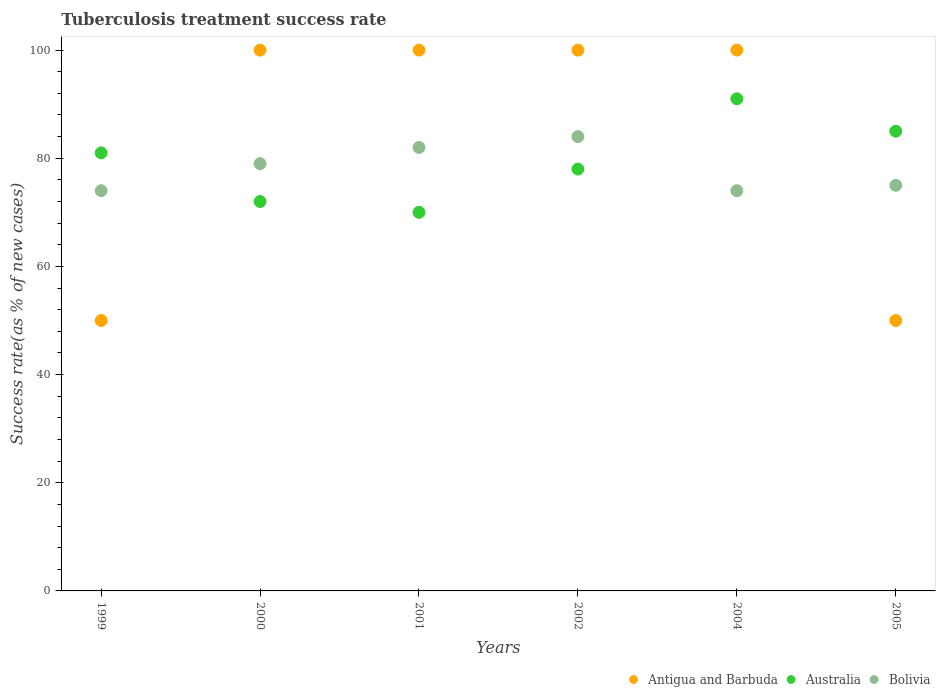How many different coloured dotlines are there?
Your response must be concise. 3. Across all years, what is the maximum tuberculosis treatment success rate in Australia?
Provide a short and direct response. 91. Across all years, what is the minimum tuberculosis treatment success rate in Antigua and Barbuda?
Provide a succinct answer. 50. What is the total tuberculosis treatment success rate in Australia in the graph?
Provide a short and direct response. 477. What is the difference between the tuberculosis treatment success rate in Bolivia in 1999 and that in 2004?
Ensure brevity in your answer.  0. Is the tuberculosis treatment success rate in Australia in 2000 less than that in 2004?
Your answer should be compact. Yes. Is the difference between the tuberculosis treatment success rate in Bolivia in 2001 and 2002 greater than the difference between the tuberculosis treatment success rate in Australia in 2001 and 2002?
Keep it short and to the point. Yes. Is it the case that in every year, the sum of the tuberculosis treatment success rate in Antigua and Barbuda and tuberculosis treatment success rate in Australia  is greater than the tuberculosis treatment success rate in Bolivia?
Ensure brevity in your answer.  Yes. Does the tuberculosis treatment success rate in Antigua and Barbuda monotonically increase over the years?
Provide a short and direct response. No. How many years are there in the graph?
Give a very brief answer. 6. Are the values on the major ticks of Y-axis written in scientific E-notation?
Your response must be concise. No. Does the graph contain any zero values?
Offer a terse response. No. Does the graph contain grids?
Provide a short and direct response. No. Where does the legend appear in the graph?
Offer a terse response. Bottom right. What is the title of the graph?
Ensure brevity in your answer.  Tuberculosis treatment success rate. Does "Canada" appear as one of the legend labels in the graph?
Offer a terse response. No. What is the label or title of the Y-axis?
Make the answer very short. Success rate(as % of new cases). What is the Success rate(as % of new cases) in Antigua and Barbuda in 1999?
Your answer should be compact. 50. What is the Success rate(as % of new cases) of Australia in 1999?
Offer a very short reply. 81. What is the Success rate(as % of new cases) of Antigua and Barbuda in 2000?
Ensure brevity in your answer.  100. What is the Success rate(as % of new cases) in Australia in 2000?
Offer a terse response. 72. What is the Success rate(as % of new cases) of Bolivia in 2000?
Provide a short and direct response. 79. What is the Success rate(as % of new cases) of Antigua and Barbuda in 2001?
Ensure brevity in your answer.  100. What is the Success rate(as % of new cases) in Antigua and Barbuda in 2002?
Ensure brevity in your answer.  100. What is the Success rate(as % of new cases) in Bolivia in 2002?
Ensure brevity in your answer.  84. What is the Success rate(as % of new cases) of Antigua and Barbuda in 2004?
Keep it short and to the point. 100. What is the Success rate(as % of new cases) in Australia in 2004?
Your answer should be very brief. 91. What is the Success rate(as % of new cases) of Bolivia in 2004?
Offer a terse response. 74. What is the Success rate(as % of new cases) of Antigua and Barbuda in 2005?
Your answer should be very brief. 50. What is the Success rate(as % of new cases) in Australia in 2005?
Offer a very short reply. 85. What is the Success rate(as % of new cases) of Bolivia in 2005?
Your answer should be very brief. 75. Across all years, what is the maximum Success rate(as % of new cases) of Antigua and Barbuda?
Provide a succinct answer. 100. Across all years, what is the maximum Success rate(as % of new cases) in Australia?
Provide a short and direct response. 91. Across all years, what is the maximum Success rate(as % of new cases) of Bolivia?
Offer a very short reply. 84. Across all years, what is the minimum Success rate(as % of new cases) of Bolivia?
Your response must be concise. 74. What is the total Success rate(as % of new cases) in Australia in the graph?
Keep it short and to the point. 477. What is the total Success rate(as % of new cases) of Bolivia in the graph?
Your response must be concise. 468. What is the difference between the Success rate(as % of new cases) in Bolivia in 1999 and that in 2000?
Your response must be concise. -5. What is the difference between the Success rate(as % of new cases) of Antigua and Barbuda in 1999 and that in 2001?
Make the answer very short. -50. What is the difference between the Success rate(as % of new cases) of Antigua and Barbuda in 1999 and that in 2002?
Your answer should be compact. -50. What is the difference between the Success rate(as % of new cases) of Australia in 1999 and that in 2002?
Offer a very short reply. 3. What is the difference between the Success rate(as % of new cases) in Antigua and Barbuda in 1999 and that in 2004?
Ensure brevity in your answer.  -50. What is the difference between the Success rate(as % of new cases) of Antigua and Barbuda in 1999 and that in 2005?
Your response must be concise. 0. What is the difference between the Success rate(as % of new cases) in Australia in 1999 and that in 2005?
Keep it short and to the point. -4. What is the difference between the Success rate(as % of new cases) of Australia in 2000 and that in 2001?
Offer a terse response. 2. What is the difference between the Success rate(as % of new cases) of Bolivia in 2000 and that in 2001?
Give a very brief answer. -3. What is the difference between the Success rate(as % of new cases) in Australia in 2000 and that in 2002?
Your answer should be compact. -6. What is the difference between the Success rate(as % of new cases) of Australia in 2000 and that in 2004?
Keep it short and to the point. -19. What is the difference between the Success rate(as % of new cases) in Bolivia in 2000 and that in 2004?
Offer a very short reply. 5. What is the difference between the Success rate(as % of new cases) in Antigua and Barbuda in 2000 and that in 2005?
Provide a short and direct response. 50. What is the difference between the Success rate(as % of new cases) in Australia in 2000 and that in 2005?
Provide a short and direct response. -13. What is the difference between the Success rate(as % of new cases) of Australia in 2001 and that in 2002?
Make the answer very short. -8. What is the difference between the Success rate(as % of new cases) in Antigua and Barbuda in 2001 and that in 2004?
Your response must be concise. 0. What is the difference between the Success rate(as % of new cases) in Bolivia in 2001 and that in 2004?
Ensure brevity in your answer.  8. What is the difference between the Success rate(as % of new cases) in Bolivia in 2001 and that in 2005?
Ensure brevity in your answer.  7. What is the difference between the Success rate(as % of new cases) in Antigua and Barbuda in 2002 and that in 2004?
Offer a very short reply. 0. What is the difference between the Success rate(as % of new cases) in Australia in 2002 and that in 2004?
Provide a succinct answer. -13. What is the difference between the Success rate(as % of new cases) of Bolivia in 2002 and that in 2004?
Your answer should be very brief. 10. What is the difference between the Success rate(as % of new cases) in Antigua and Barbuda in 2002 and that in 2005?
Offer a terse response. 50. What is the difference between the Success rate(as % of new cases) in Bolivia in 2002 and that in 2005?
Make the answer very short. 9. What is the difference between the Success rate(as % of new cases) in Australia in 2004 and that in 2005?
Your answer should be very brief. 6. What is the difference between the Success rate(as % of new cases) in Antigua and Barbuda in 1999 and the Success rate(as % of new cases) in Bolivia in 2000?
Your answer should be very brief. -29. What is the difference between the Success rate(as % of new cases) in Australia in 1999 and the Success rate(as % of new cases) in Bolivia in 2000?
Your response must be concise. 2. What is the difference between the Success rate(as % of new cases) of Antigua and Barbuda in 1999 and the Success rate(as % of new cases) of Bolivia in 2001?
Offer a very short reply. -32. What is the difference between the Success rate(as % of new cases) in Australia in 1999 and the Success rate(as % of new cases) in Bolivia in 2001?
Give a very brief answer. -1. What is the difference between the Success rate(as % of new cases) in Antigua and Barbuda in 1999 and the Success rate(as % of new cases) in Australia in 2002?
Your response must be concise. -28. What is the difference between the Success rate(as % of new cases) in Antigua and Barbuda in 1999 and the Success rate(as % of new cases) in Bolivia in 2002?
Your answer should be very brief. -34. What is the difference between the Success rate(as % of new cases) of Antigua and Barbuda in 1999 and the Success rate(as % of new cases) of Australia in 2004?
Your answer should be compact. -41. What is the difference between the Success rate(as % of new cases) of Antigua and Barbuda in 1999 and the Success rate(as % of new cases) of Bolivia in 2004?
Your response must be concise. -24. What is the difference between the Success rate(as % of new cases) in Australia in 1999 and the Success rate(as % of new cases) in Bolivia in 2004?
Your answer should be compact. 7. What is the difference between the Success rate(as % of new cases) of Antigua and Barbuda in 1999 and the Success rate(as % of new cases) of Australia in 2005?
Keep it short and to the point. -35. What is the difference between the Success rate(as % of new cases) of Antigua and Barbuda in 1999 and the Success rate(as % of new cases) of Bolivia in 2005?
Provide a succinct answer. -25. What is the difference between the Success rate(as % of new cases) of Antigua and Barbuda in 2000 and the Success rate(as % of new cases) of Bolivia in 2001?
Keep it short and to the point. 18. What is the difference between the Success rate(as % of new cases) in Australia in 2000 and the Success rate(as % of new cases) in Bolivia in 2001?
Your answer should be compact. -10. What is the difference between the Success rate(as % of new cases) of Antigua and Barbuda in 2000 and the Success rate(as % of new cases) of Bolivia in 2002?
Make the answer very short. 16. What is the difference between the Success rate(as % of new cases) of Australia in 2000 and the Success rate(as % of new cases) of Bolivia in 2002?
Your response must be concise. -12. What is the difference between the Success rate(as % of new cases) in Antigua and Barbuda in 2000 and the Success rate(as % of new cases) in Australia in 2004?
Offer a very short reply. 9. What is the difference between the Success rate(as % of new cases) in Antigua and Barbuda in 2000 and the Success rate(as % of new cases) in Australia in 2005?
Make the answer very short. 15. What is the difference between the Success rate(as % of new cases) of Australia in 2001 and the Success rate(as % of new cases) of Bolivia in 2002?
Give a very brief answer. -14. What is the difference between the Success rate(as % of new cases) of Australia in 2001 and the Success rate(as % of new cases) of Bolivia in 2004?
Make the answer very short. -4. What is the difference between the Success rate(as % of new cases) of Antigua and Barbuda in 2001 and the Success rate(as % of new cases) of Bolivia in 2005?
Keep it short and to the point. 25. What is the difference between the Success rate(as % of new cases) of Australia in 2002 and the Success rate(as % of new cases) of Bolivia in 2004?
Provide a short and direct response. 4. What is the difference between the Success rate(as % of new cases) of Australia in 2004 and the Success rate(as % of new cases) of Bolivia in 2005?
Your answer should be compact. 16. What is the average Success rate(as % of new cases) of Antigua and Barbuda per year?
Keep it short and to the point. 83.33. What is the average Success rate(as % of new cases) in Australia per year?
Keep it short and to the point. 79.5. In the year 1999, what is the difference between the Success rate(as % of new cases) in Antigua and Barbuda and Success rate(as % of new cases) in Australia?
Keep it short and to the point. -31. In the year 1999, what is the difference between the Success rate(as % of new cases) in Antigua and Barbuda and Success rate(as % of new cases) in Bolivia?
Give a very brief answer. -24. In the year 2000, what is the difference between the Success rate(as % of new cases) in Antigua and Barbuda and Success rate(as % of new cases) in Bolivia?
Provide a succinct answer. 21. In the year 2000, what is the difference between the Success rate(as % of new cases) of Australia and Success rate(as % of new cases) of Bolivia?
Provide a short and direct response. -7. In the year 2001, what is the difference between the Success rate(as % of new cases) of Antigua and Barbuda and Success rate(as % of new cases) of Australia?
Offer a very short reply. 30. In the year 2001, what is the difference between the Success rate(as % of new cases) in Antigua and Barbuda and Success rate(as % of new cases) in Bolivia?
Give a very brief answer. 18. In the year 2002, what is the difference between the Success rate(as % of new cases) of Antigua and Barbuda and Success rate(as % of new cases) of Australia?
Ensure brevity in your answer.  22. In the year 2002, what is the difference between the Success rate(as % of new cases) of Antigua and Barbuda and Success rate(as % of new cases) of Bolivia?
Provide a short and direct response. 16. In the year 2004, what is the difference between the Success rate(as % of new cases) in Australia and Success rate(as % of new cases) in Bolivia?
Your answer should be very brief. 17. In the year 2005, what is the difference between the Success rate(as % of new cases) in Antigua and Barbuda and Success rate(as % of new cases) in Australia?
Ensure brevity in your answer.  -35. In the year 2005, what is the difference between the Success rate(as % of new cases) of Antigua and Barbuda and Success rate(as % of new cases) of Bolivia?
Your answer should be compact. -25. What is the ratio of the Success rate(as % of new cases) in Antigua and Barbuda in 1999 to that in 2000?
Provide a short and direct response. 0.5. What is the ratio of the Success rate(as % of new cases) of Australia in 1999 to that in 2000?
Provide a short and direct response. 1.12. What is the ratio of the Success rate(as % of new cases) of Bolivia in 1999 to that in 2000?
Keep it short and to the point. 0.94. What is the ratio of the Success rate(as % of new cases) in Australia in 1999 to that in 2001?
Make the answer very short. 1.16. What is the ratio of the Success rate(as % of new cases) in Bolivia in 1999 to that in 2001?
Your response must be concise. 0.9. What is the ratio of the Success rate(as % of new cases) of Antigua and Barbuda in 1999 to that in 2002?
Provide a short and direct response. 0.5. What is the ratio of the Success rate(as % of new cases) in Bolivia in 1999 to that in 2002?
Offer a terse response. 0.88. What is the ratio of the Success rate(as % of new cases) of Australia in 1999 to that in 2004?
Your response must be concise. 0.89. What is the ratio of the Success rate(as % of new cases) of Australia in 1999 to that in 2005?
Your response must be concise. 0.95. What is the ratio of the Success rate(as % of new cases) of Bolivia in 1999 to that in 2005?
Offer a terse response. 0.99. What is the ratio of the Success rate(as % of new cases) in Antigua and Barbuda in 2000 to that in 2001?
Keep it short and to the point. 1. What is the ratio of the Success rate(as % of new cases) of Australia in 2000 to that in 2001?
Ensure brevity in your answer.  1.03. What is the ratio of the Success rate(as % of new cases) of Bolivia in 2000 to that in 2001?
Your answer should be very brief. 0.96. What is the ratio of the Success rate(as % of new cases) of Antigua and Barbuda in 2000 to that in 2002?
Your response must be concise. 1. What is the ratio of the Success rate(as % of new cases) in Bolivia in 2000 to that in 2002?
Your answer should be very brief. 0.94. What is the ratio of the Success rate(as % of new cases) of Australia in 2000 to that in 2004?
Your answer should be very brief. 0.79. What is the ratio of the Success rate(as % of new cases) in Bolivia in 2000 to that in 2004?
Provide a short and direct response. 1.07. What is the ratio of the Success rate(as % of new cases) of Australia in 2000 to that in 2005?
Offer a terse response. 0.85. What is the ratio of the Success rate(as % of new cases) in Bolivia in 2000 to that in 2005?
Your answer should be very brief. 1.05. What is the ratio of the Success rate(as % of new cases) of Australia in 2001 to that in 2002?
Offer a terse response. 0.9. What is the ratio of the Success rate(as % of new cases) of Bolivia in 2001 to that in 2002?
Offer a terse response. 0.98. What is the ratio of the Success rate(as % of new cases) in Australia in 2001 to that in 2004?
Offer a terse response. 0.77. What is the ratio of the Success rate(as % of new cases) of Bolivia in 2001 to that in 2004?
Keep it short and to the point. 1.11. What is the ratio of the Success rate(as % of new cases) of Antigua and Barbuda in 2001 to that in 2005?
Offer a very short reply. 2. What is the ratio of the Success rate(as % of new cases) in Australia in 2001 to that in 2005?
Your response must be concise. 0.82. What is the ratio of the Success rate(as % of new cases) of Bolivia in 2001 to that in 2005?
Your answer should be very brief. 1.09. What is the ratio of the Success rate(as % of new cases) in Antigua and Barbuda in 2002 to that in 2004?
Offer a terse response. 1. What is the ratio of the Success rate(as % of new cases) in Bolivia in 2002 to that in 2004?
Give a very brief answer. 1.14. What is the ratio of the Success rate(as % of new cases) in Australia in 2002 to that in 2005?
Your response must be concise. 0.92. What is the ratio of the Success rate(as % of new cases) of Bolivia in 2002 to that in 2005?
Your answer should be compact. 1.12. What is the ratio of the Success rate(as % of new cases) of Australia in 2004 to that in 2005?
Offer a very short reply. 1.07. What is the ratio of the Success rate(as % of new cases) in Bolivia in 2004 to that in 2005?
Give a very brief answer. 0.99. What is the difference between the highest and the lowest Success rate(as % of new cases) of Antigua and Barbuda?
Provide a succinct answer. 50. What is the difference between the highest and the lowest Success rate(as % of new cases) of Australia?
Your response must be concise. 21. 